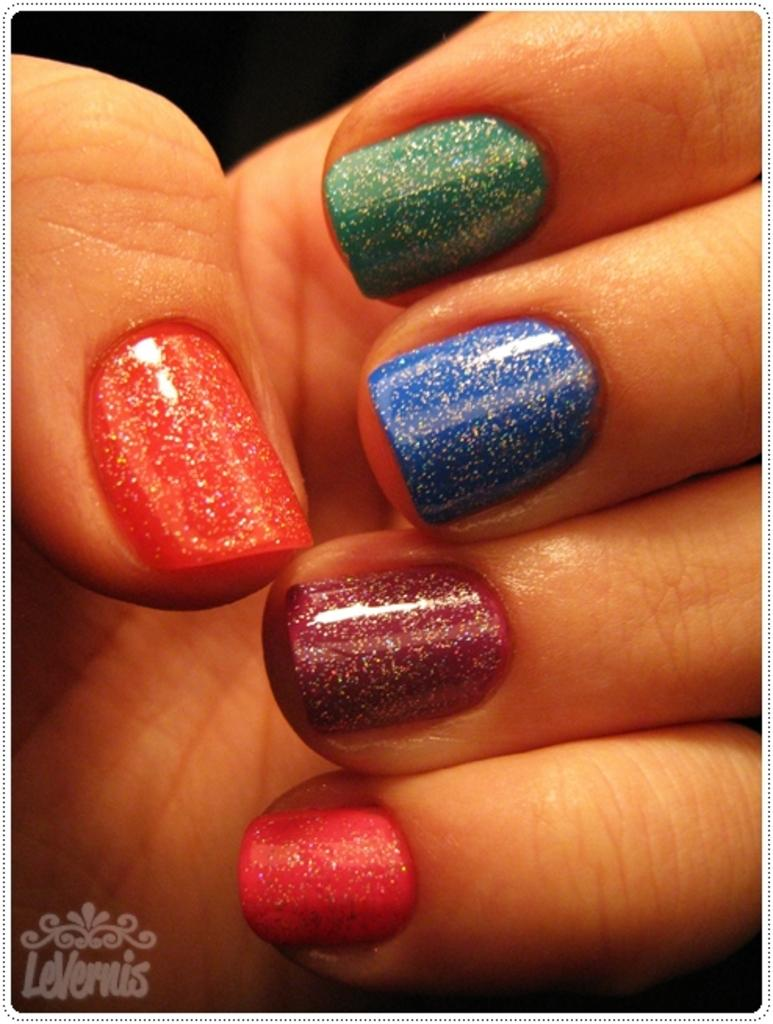What part of the body is visible in the image? The image shows the fingers of a person. What can be seen on the nails of the fingers? There are nail paints on the nails. How does the coach react to the earthquake in the image? There is no coach or earthquake present in the image; it only shows the fingers of a person with nail paints. 